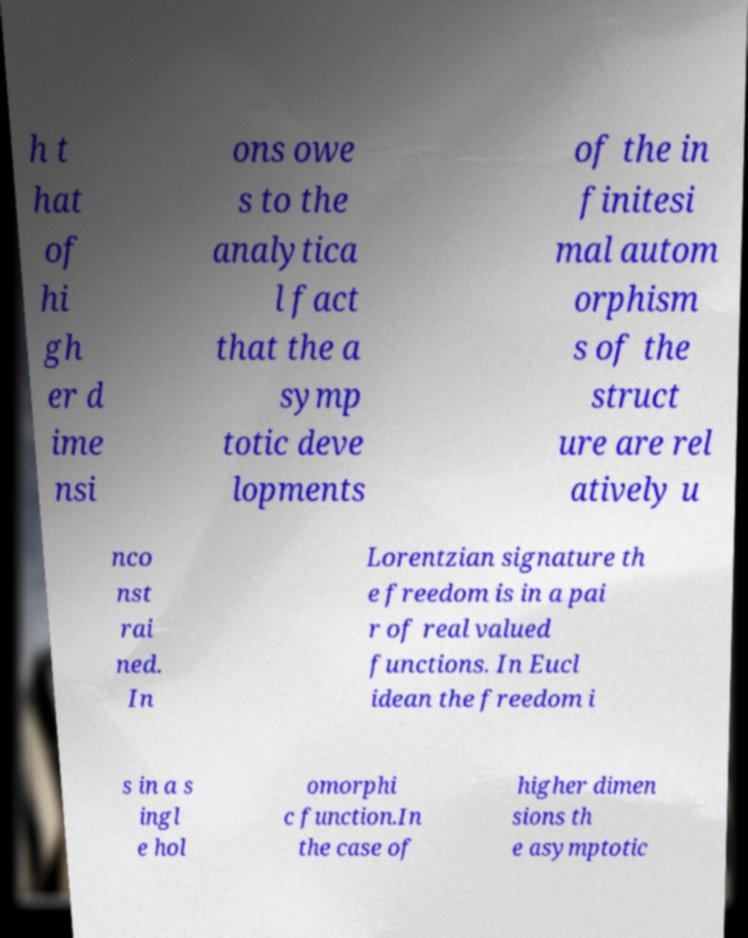What messages or text are displayed in this image? I need them in a readable, typed format. h t hat of hi gh er d ime nsi ons owe s to the analytica l fact that the a symp totic deve lopments of the in finitesi mal autom orphism s of the struct ure are rel atively u nco nst rai ned. In Lorentzian signature th e freedom is in a pai r of real valued functions. In Eucl idean the freedom i s in a s ingl e hol omorphi c function.In the case of higher dimen sions th e asymptotic 